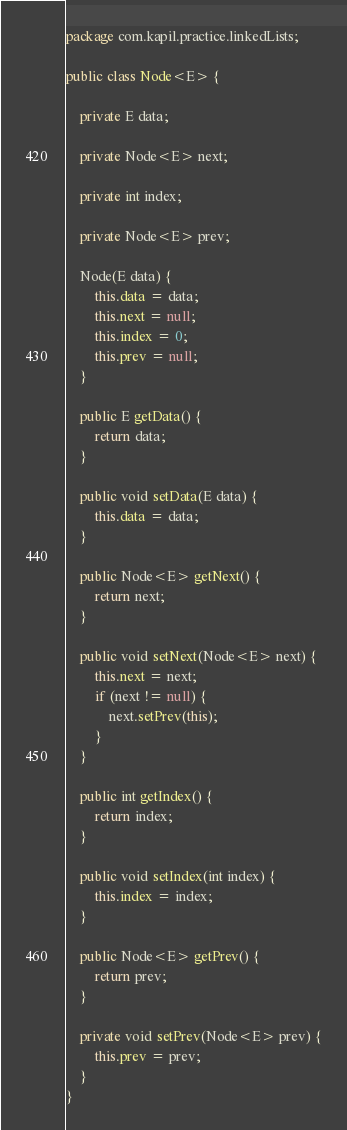<code> <loc_0><loc_0><loc_500><loc_500><_Java_>package com.kapil.practice.linkedLists;

public class Node<E> {

	private E data;

	private Node<E> next;

	private int index;

	private Node<E> prev;

	Node(E data) {
		this.data = data;
		this.next = null;
		this.index = 0;
		this.prev = null;
	}

	public E getData() {
		return data;
	}

	public void setData(E data) {
		this.data = data;
	}

	public Node<E> getNext() {
		return next;
	}

	public void setNext(Node<E> next) {
		this.next = next;
		if (next != null) {
			next.setPrev(this);
		}
	}

	public int getIndex() {
		return index;
	}

	public void setIndex(int index) {
		this.index = index;
	}

	public Node<E> getPrev() {
		return prev;
	}

	private void setPrev(Node<E> prev) {
		this.prev = prev;
	}
}
</code> 